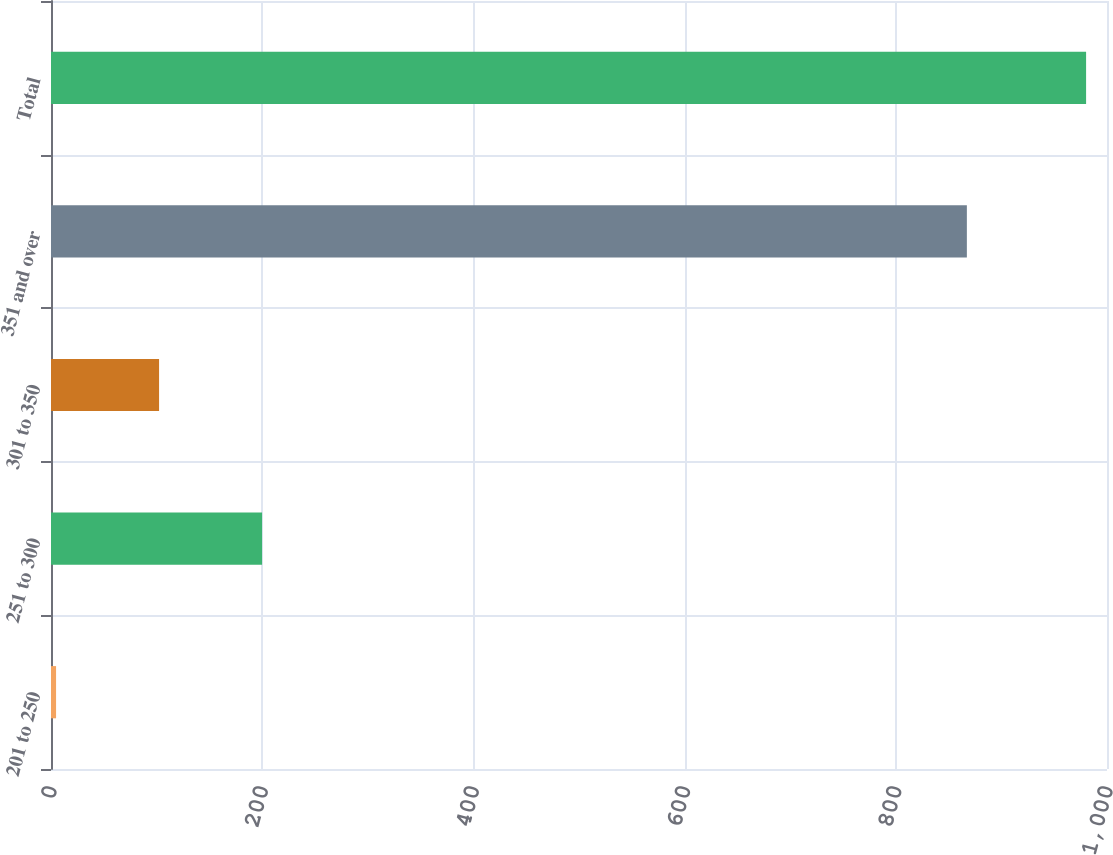Convert chart to OTSL. <chart><loc_0><loc_0><loc_500><loc_500><bar_chart><fcel>201 to 250<fcel>251 to 300<fcel>301 to 350<fcel>351 and over<fcel>Total<nl><fcel>4.8<fcel>199.88<fcel>102.34<fcel>867.3<fcel>980.2<nl></chart> 